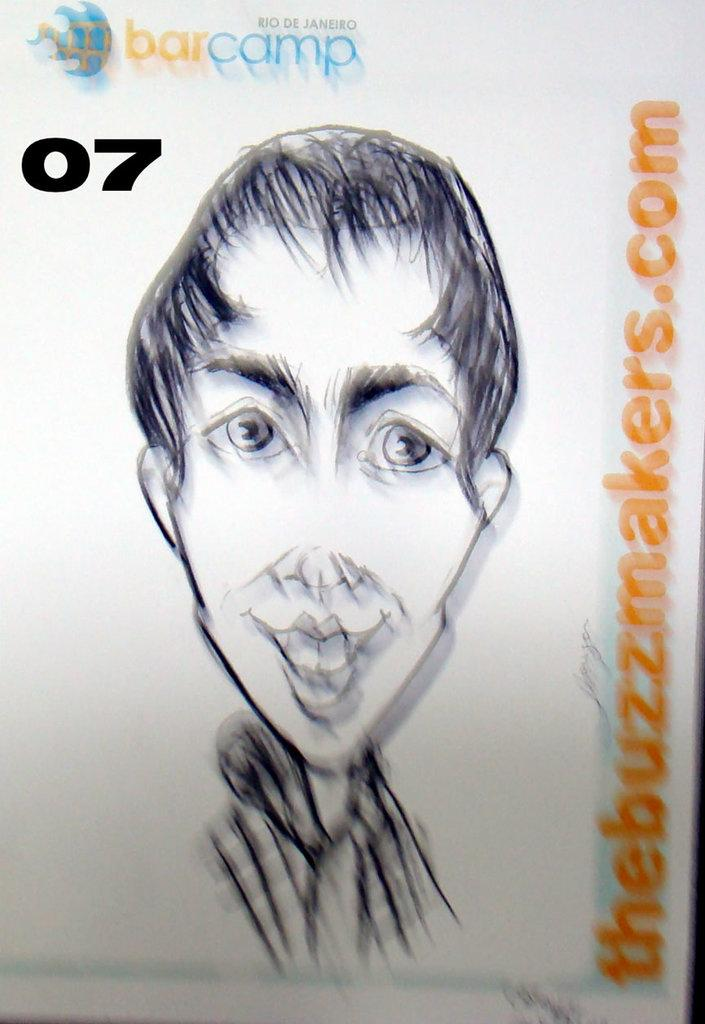What is featured on the poster in the image? The poster in the image contains text and a drawing of a person. Can you describe the drawing on the poster? The drawing on the poster is of a person. What is the purpose of the text on the poster? The purpose of the text on the poster is not specified in the given facts, but it could be to convey a message or provide information about the person depicted. What type of cream is being applied to the horn in the image? There is no cream or horn present in the image; it only features a poster with text and a drawing of a person. 